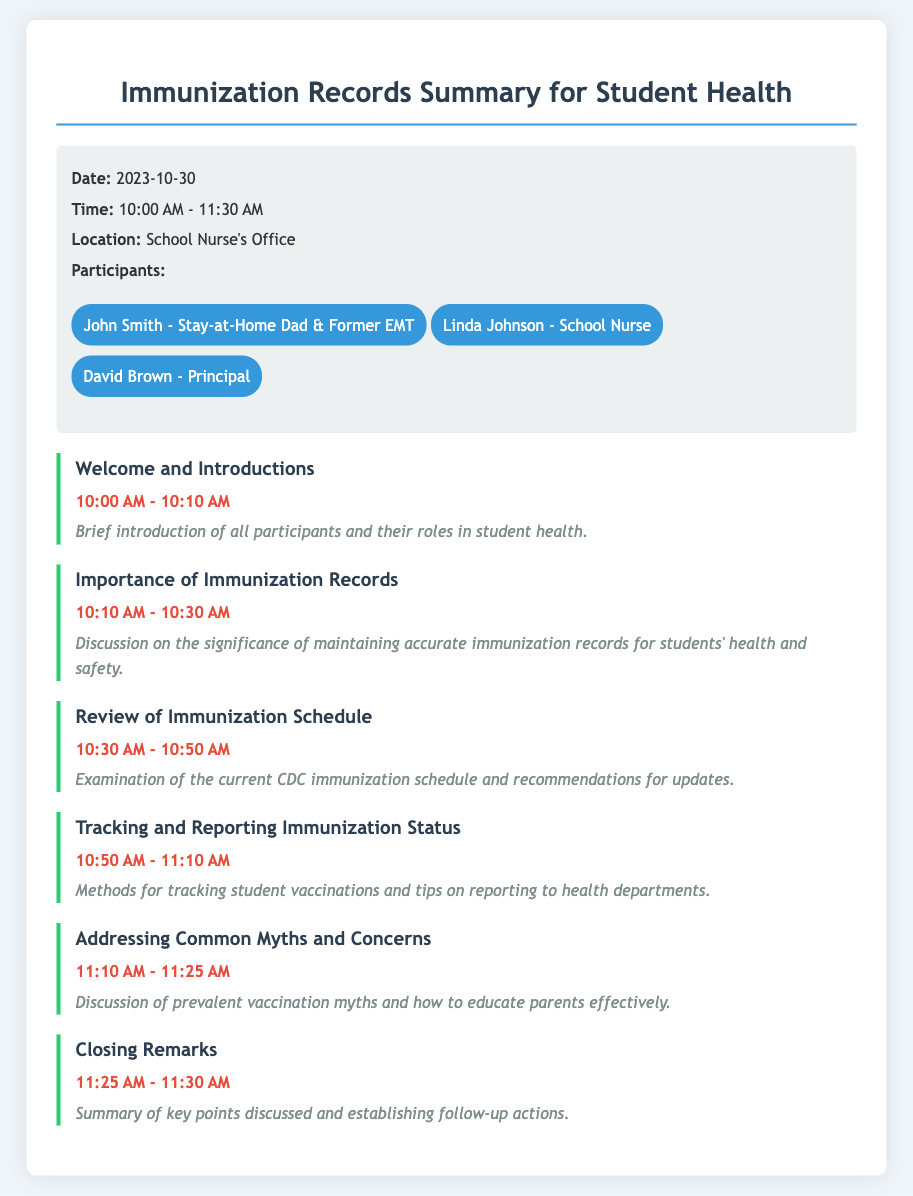What is the date of the meeting? The date of the meeting can be found in the information section at the top of the document.
Answer: 2023-10-30 What time does the meeting start? The starting time of the meeting is listed in the information section under time.
Answer: 10:00 AM Who is the school nurse participating in the meeting? The document lists the participants in a bullet list, including the school nurse's name.
Answer: Linda Johnson What is the title of the first agenda item? The first item in the agenda section is a key focus of the meeting.
Answer: Welcome and Introductions Which agenda item discusses vaccination myths? This item is part of the agenda and focuses on addressing misconceptions related to vaccinations.
Answer: Addressing Common Myths and Concerns What time is allocated for the "Review of Immunization Schedule"? The time allotted for this specific agenda item is provided in the timeline for the meeting.
Answer: 10:30 AM - 10:50 AM How many total agenda items are listed in the document? By counting the agenda items listed, we can find the total number of specific discussions planned.
Answer: Six What is the purpose of the meeting? The overall aim of the meeting can be inferred from the title and agenda.
Answer: Immunization Records Summary What color is used for the agenda item titles? The color for the agenda item headers is specified in the document's styling.
Answer: Dark Blue 